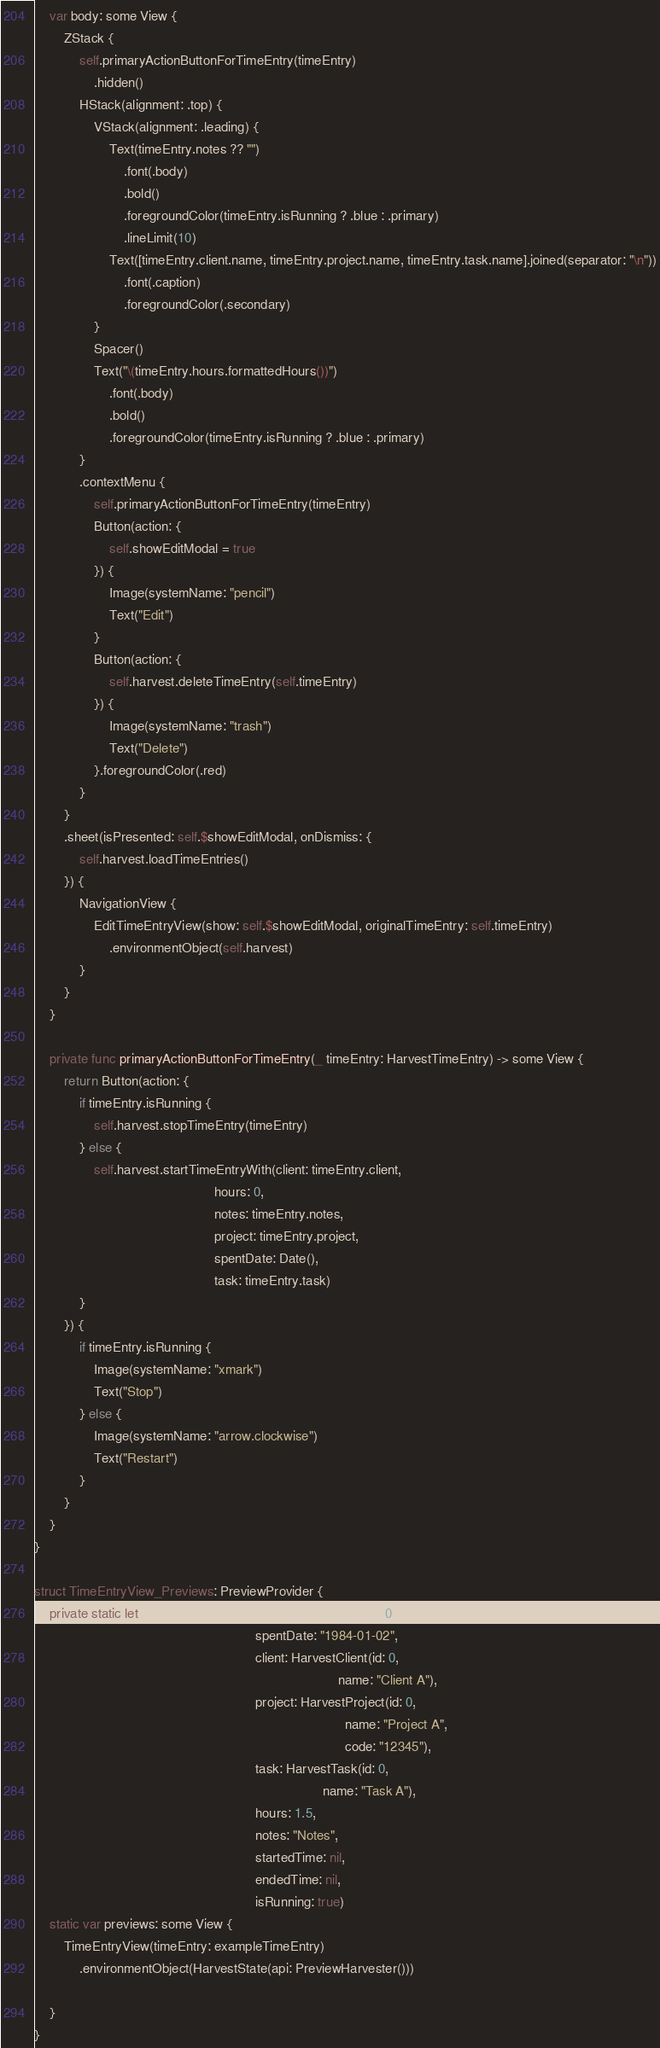<code> <loc_0><loc_0><loc_500><loc_500><_Swift_>
    var body: some View {
        ZStack {
            self.primaryActionButtonForTimeEntry(timeEntry)
                .hidden()
            HStack(alignment: .top) {
                VStack(alignment: .leading) {
                    Text(timeEntry.notes ?? "")
                        .font(.body)
                        .bold()
                        .foregroundColor(timeEntry.isRunning ? .blue : .primary)
                        .lineLimit(10)
                    Text([timeEntry.client.name, timeEntry.project.name, timeEntry.task.name].joined(separator: "\n"))
                        .font(.caption)
                        .foregroundColor(.secondary)
                }
                Spacer()
                Text("\(timeEntry.hours.formattedHours())")
                    .font(.body)
                    .bold()
                    .foregroundColor(timeEntry.isRunning ? .blue : .primary)
            }
            .contextMenu {
                self.primaryActionButtonForTimeEntry(timeEntry)
                Button(action: {
                    self.showEditModal = true
                }) {
                    Image(systemName: "pencil")
                    Text("Edit")
                }
                Button(action: {
                    self.harvest.deleteTimeEntry(self.timeEntry)
                }) {
                    Image(systemName: "trash")
                    Text("Delete")
                }.foregroundColor(.red)
            }
        }
        .sheet(isPresented: self.$showEditModal, onDismiss: {
            self.harvest.loadTimeEntries()
        }) {
            NavigationView {
                EditTimeEntryView(show: self.$showEditModal, originalTimeEntry: self.timeEntry)
                    .environmentObject(self.harvest)
            }
        }
    }

    private func primaryActionButtonForTimeEntry(_ timeEntry: HarvestTimeEntry) -> some View {
        return Button(action: {
            if timeEntry.isRunning {
                self.harvest.stopTimeEntry(timeEntry)
            } else {
                self.harvest.startTimeEntryWith(client: timeEntry.client,
                                                hours: 0,
                                                notes: timeEntry.notes,
                                                project: timeEntry.project,
                                                spentDate: Date(),
                                                task: timeEntry.task)
            }
        }) {
            if timeEntry.isRunning {
                Image(systemName: "xmark")
                Text("Stop")
            } else {
                Image(systemName: "arrow.clockwise")
                Text("Restart")
            }
        }
    }
}

struct TimeEntryView_Previews: PreviewProvider {
    private static let exampleTimeEntry = HarvestTimeEntry(id: 0,
                                                           spentDate: "1984-01-02",
                                                           client: HarvestClient(id: 0,
                                                                                 name: "Client A"),
                                                           project: HarvestProject(id: 0,
                                                                                   name: "Project A",
                                                                                   code: "12345"),
                                                           task: HarvestTask(id: 0,
                                                                             name: "Task A"),
                                                           hours: 1.5,
                                                           notes: "Notes",
                                                           startedTime: nil,
                                                           endedTime: nil,
                                                           isRunning: true)
    static var previews: some View {
        TimeEntryView(timeEntry: exampleTimeEntry)
            .environmentObject(HarvestState(api: PreviewHarvester()))

    }
}
</code> 